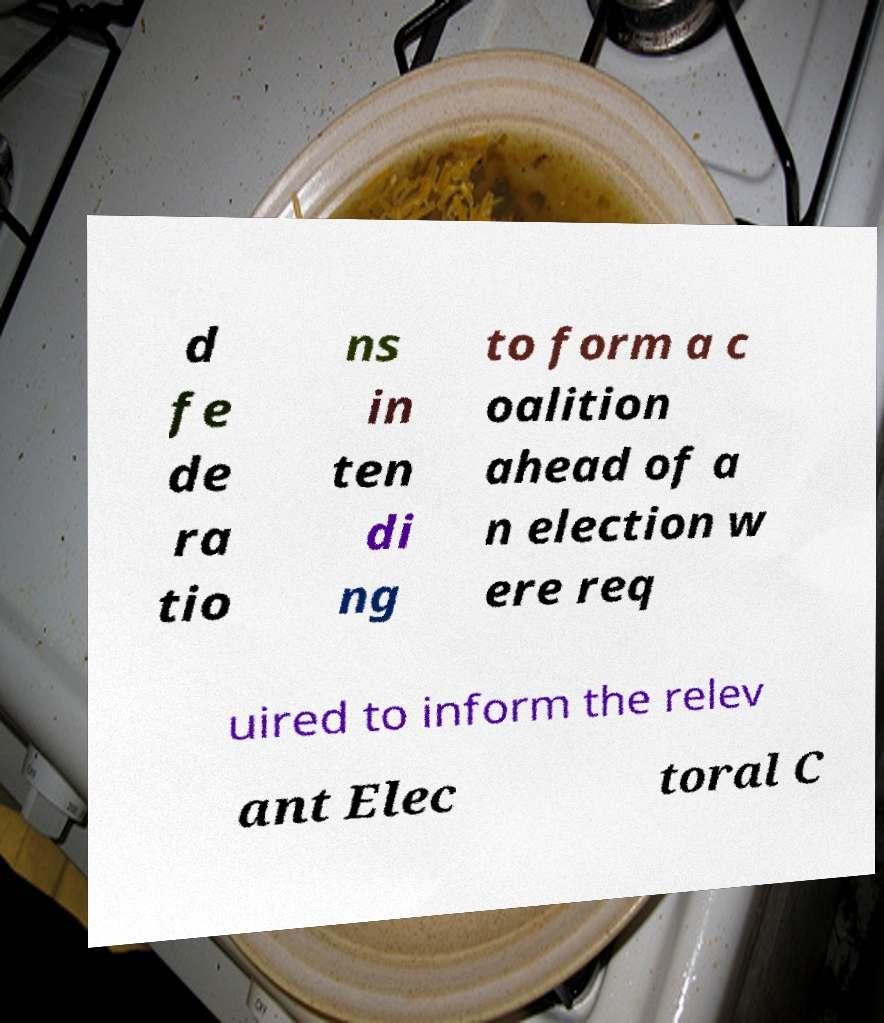Could you extract and type out the text from this image? d fe de ra tio ns in ten di ng to form a c oalition ahead of a n election w ere req uired to inform the relev ant Elec toral C 